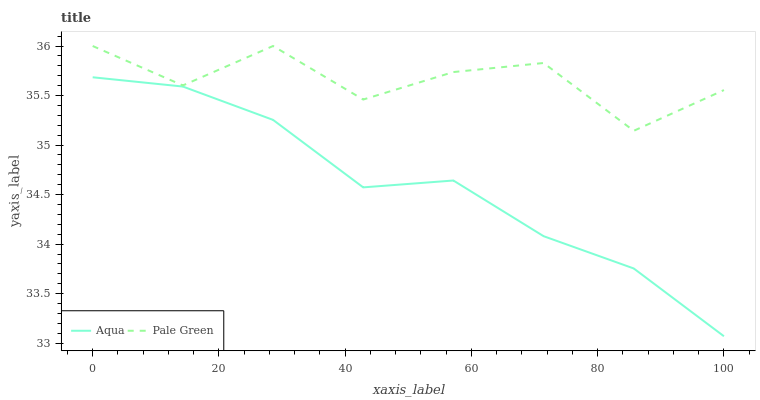Does Aqua have the minimum area under the curve?
Answer yes or no. Yes. Does Pale Green have the maximum area under the curve?
Answer yes or no. Yes. Does Aqua have the maximum area under the curve?
Answer yes or no. No. Is Aqua the smoothest?
Answer yes or no. Yes. Is Pale Green the roughest?
Answer yes or no. Yes. Is Aqua the roughest?
Answer yes or no. No. Does Pale Green have the highest value?
Answer yes or no. Yes. Does Aqua have the highest value?
Answer yes or no. No. Is Aqua less than Pale Green?
Answer yes or no. Yes. Is Pale Green greater than Aqua?
Answer yes or no. Yes. Does Aqua intersect Pale Green?
Answer yes or no. No. 